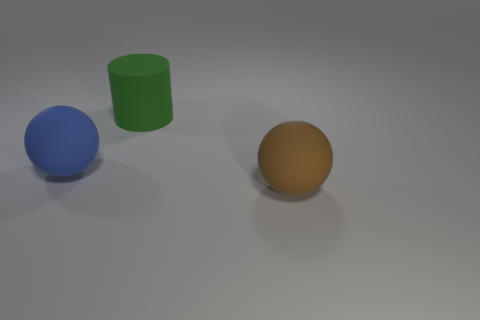There is a large green thing that is the same material as the brown ball; what shape is it?
Offer a terse response. Cylinder. The large brown object is what shape?
Your answer should be very brief. Sphere. There is a thing that is behind the brown thing and in front of the green cylinder; what color is it?
Offer a terse response. Blue. The brown rubber object that is the same size as the green object is what shape?
Your response must be concise. Sphere. Are there any big blue rubber things that have the same shape as the brown matte object?
Your answer should be compact. Yes. Is the material of the big green cylinder the same as the brown sphere that is to the right of the blue sphere?
Ensure brevity in your answer.  Yes. The sphere that is behind the big object in front of the matte ball on the left side of the big brown matte sphere is what color?
Your answer should be compact. Blue. There is a ball that is the same size as the brown rubber thing; what material is it?
Offer a very short reply. Rubber. How many large brown things are made of the same material as the large green cylinder?
Your answer should be very brief. 1. Does the ball in front of the big blue matte object have the same size as the sphere that is to the left of the green matte object?
Offer a terse response. Yes. 